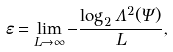<formula> <loc_0><loc_0><loc_500><loc_500>\varepsilon = \lim _ { L \rightarrow \infty } - \frac { \log _ { 2 } \Lambda ^ { 2 } ( \Psi ) } { L } ,</formula> 